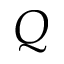Convert formula to latex. <formula><loc_0><loc_0><loc_500><loc_500>Q</formula> 